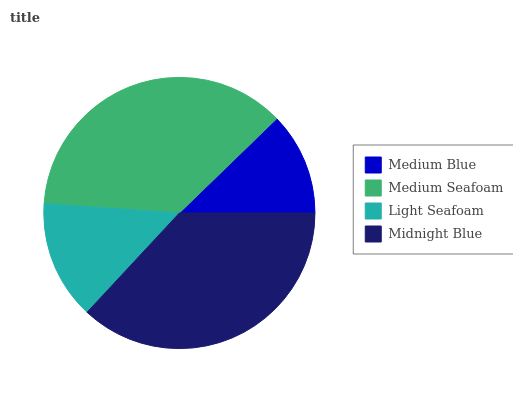Is Medium Blue the minimum?
Answer yes or no. Yes. Is Midnight Blue the maximum?
Answer yes or no. Yes. Is Medium Seafoam the minimum?
Answer yes or no. No. Is Medium Seafoam the maximum?
Answer yes or no. No. Is Medium Seafoam greater than Medium Blue?
Answer yes or no. Yes. Is Medium Blue less than Medium Seafoam?
Answer yes or no. Yes. Is Medium Blue greater than Medium Seafoam?
Answer yes or no. No. Is Medium Seafoam less than Medium Blue?
Answer yes or no. No. Is Medium Seafoam the high median?
Answer yes or no. Yes. Is Light Seafoam the low median?
Answer yes or no. Yes. Is Midnight Blue the high median?
Answer yes or no. No. Is Medium Seafoam the low median?
Answer yes or no. No. 